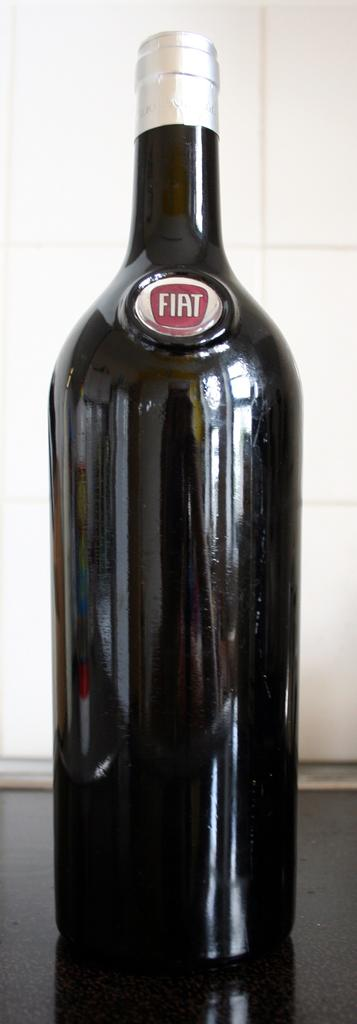<image>
Relay a brief, clear account of the picture shown. Completely black bottle with the word FIAT on the top. 